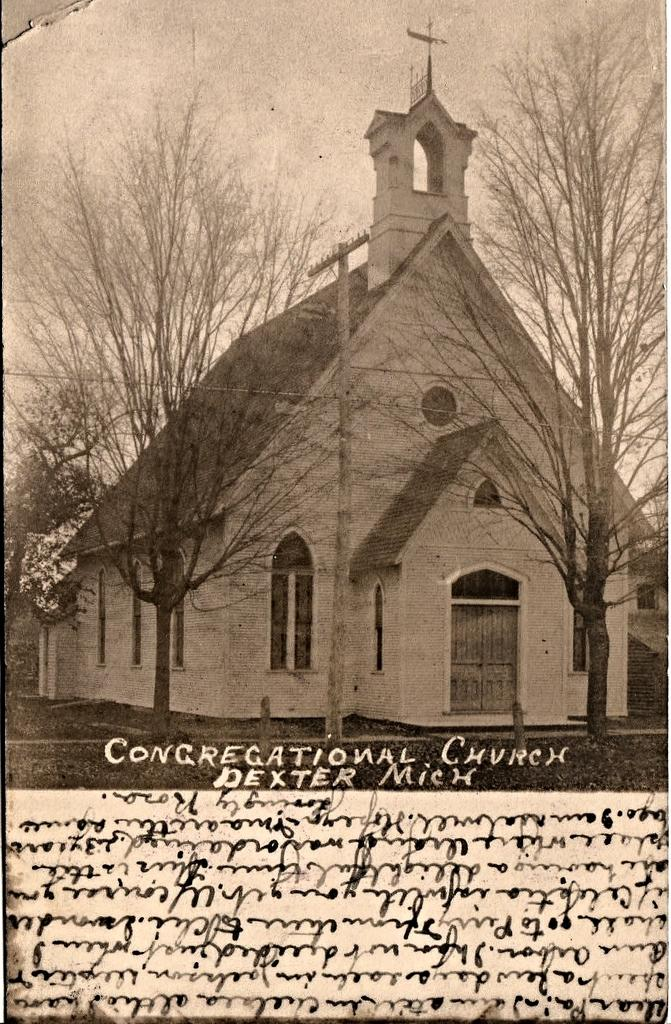<image>
Relay a brief, clear account of the picture shown. The little old church in this black and white picture is from the town of Dexter. 